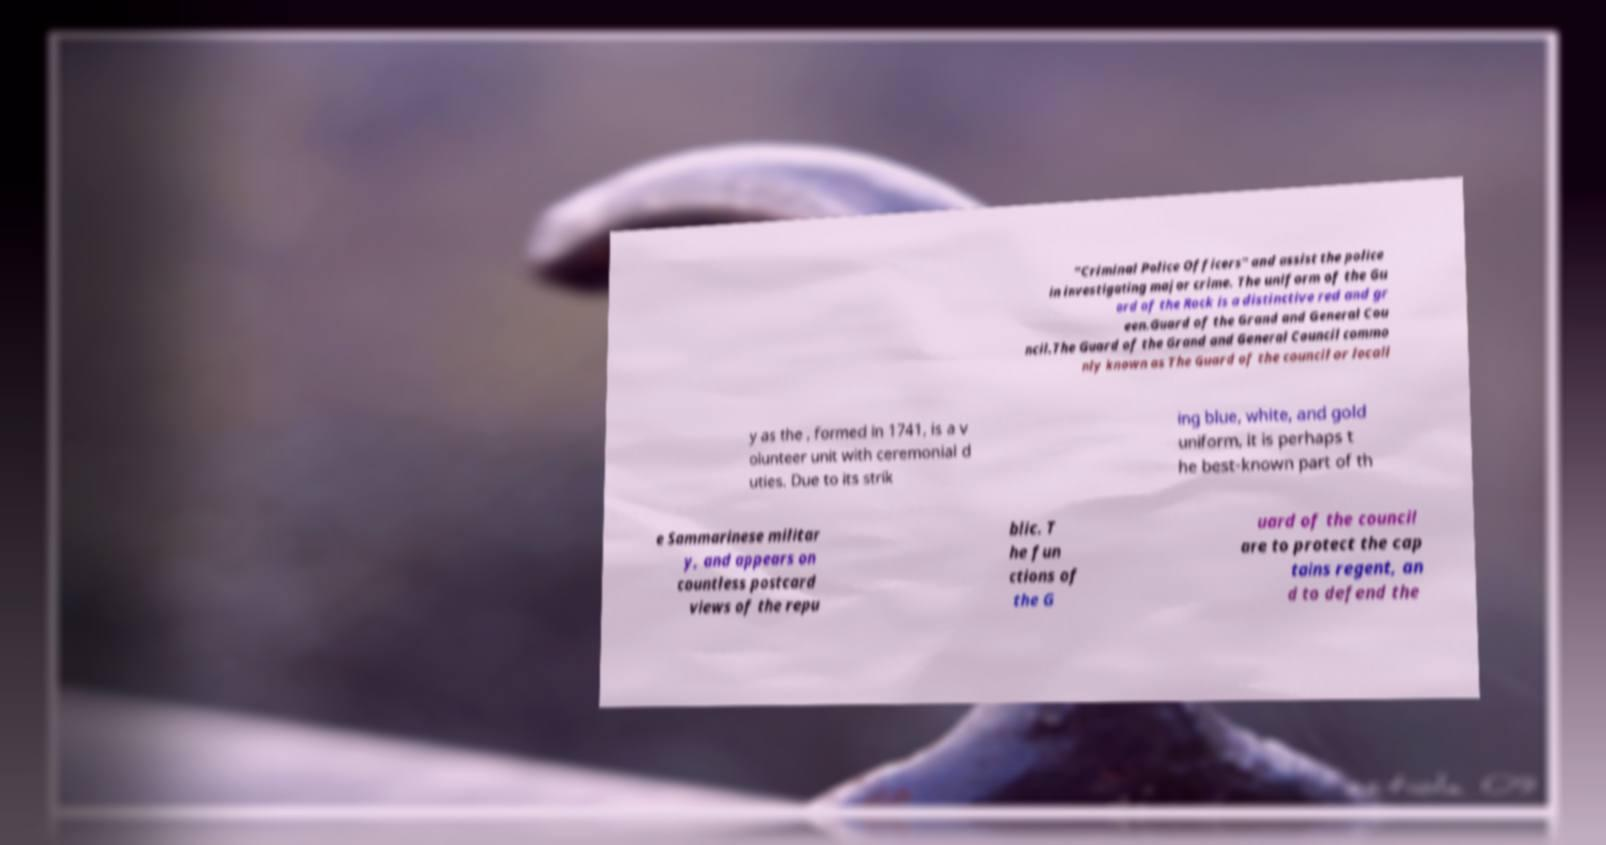What messages or text are displayed in this image? I need them in a readable, typed format. "Criminal Police Officers" and assist the police in investigating major crime. The uniform of the Gu ard of the Rock is a distinctive red and gr een.Guard of the Grand and General Cou ncil.The Guard of the Grand and General Council commo nly known as The Guard of the council or locall y as the , formed in 1741, is a v olunteer unit with ceremonial d uties. Due to its strik ing blue, white, and gold uniform, it is perhaps t he best-known part of th e Sammarinese militar y, and appears on countless postcard views of the repu blic. T he fun ctions of the G uard of the council are to protect the cap tains regent, an d to defend the 